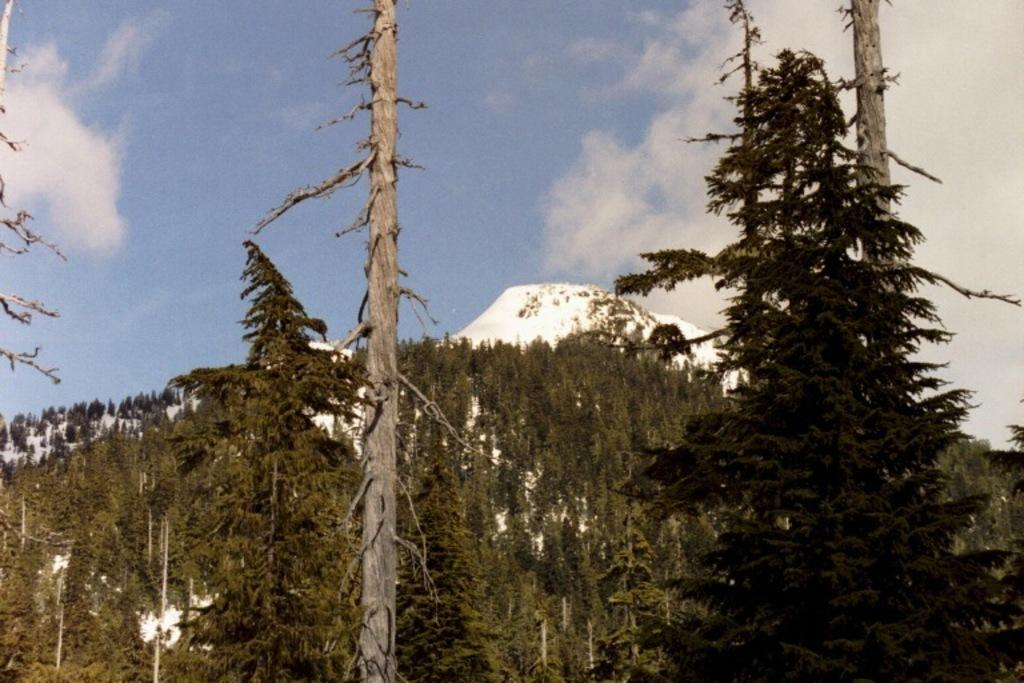What type of vegetation is in the foreground of the image? There are trees in the foreground of the image. What type of geographical feature is in the background of the image? There are mountains in the background of the image. What is visible at the top of the image? The sky is visible at the top of the image. How many times has the scale been used in the image? There is no scale present in the image. Can you describe the partner's outfit in the image? There is no partner present in the image. 